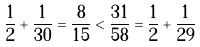<formula> <loc_0><loc_0><loc_500><loc_500>\frac { 1 } { 2 } + \frac { 1 } { 3 0 } = \frac { 8 } { 1 5 } < \frac { 3 1 } { 5 8 } = \frac { 1 } { 2 } + \frac { 1 } { 2 9 }</formula> 